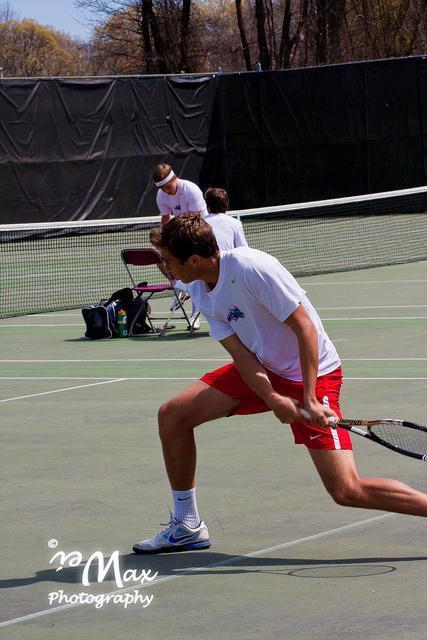How many people can you see?
Give a very brief answer. 2. 